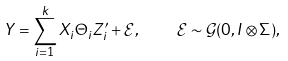<formula> <loc_0><loc_0><loc_500><loc_500>Y = \sum _ { i = 1 } ^ { k } X _ { i } \Theta _ { i } Z _ { i } ^ { \prime } + \mathcal { E } , \quad \mathcal { E } \sim \mathcal { G } ( 0 , I \otimes \Sigma ) ,</formula> 